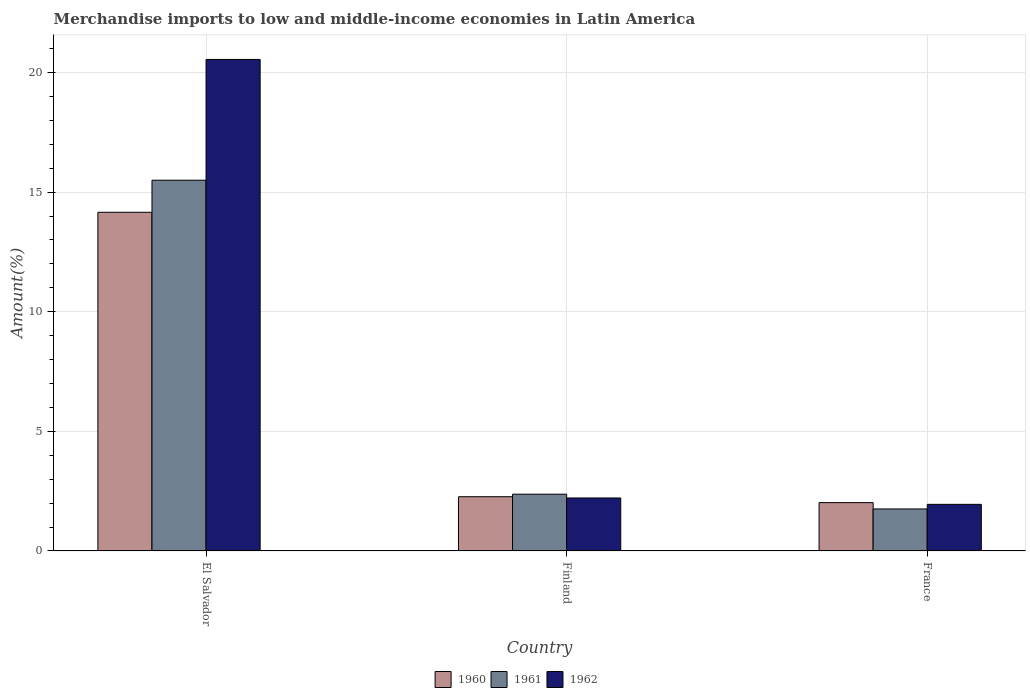How many different coloured bars are there?
Provide a succinct answer. 3. How many groups of bars are there?
Offer a very short reply. 3. Are the number of bars per tick equal to the number of legend labels?
Offer a terse response. Yes. Are the number of bars on each tick of the X-axis equal?
Your answer should be compact. Yes. What is the label of the 1st group of bars from the left?
Offer a terse response. El Salvador. What is the percentage of amount earned from merchandise imports in 1960 in France?
Ensure brevity in your answer.  2.02. Across all countries, what is the maximum percentage of amount earned from merchandise imports in 1961?
Ensure brevity in your answer.  15.5. Across all countries, what is the minimum percentage of amount earned from merchandise imports in 1960?
Ensure brevity in your answer.  2.02. In which country was the percentage of amount earned from merchandise imports in 1961 maximum?
Keep it short and to the point. El Salvador. In which country was the percentage of amount earned from merchandise imports in 1961 minimum?
Ensure brevity in your answer.  France. What is the total percentage of amount earned from merchandise imports in 1960 in the graph?
Your response must be concise. 18.45. What is the difference between the percentage of amount earned from merchandise imports in 1961 in El Salvador and that in France?
Your answer should be very brief. 13.74. What is the difference between the percentage of amount earned from merchandise imports in 1962 in El Salvador and the percentage of amount earned from merchandise imports in 1960 in Finland?
Give a very brief answer. 18.28. What is the average percentage of amount earned from merchandise imports in 1960 per country?
Your answer should be compact. 6.15. What is the difference between the percentage of amount earned from merchandise imports of/in 1962 and percentage of amount earned from merchandise imports of/in 1960 in France?
Your answer should be very brief. -0.07. In how many countries, is the percentage of amount earned from merchandise imports in 1962 greater than 1 %?
Offer a very short reply. 3. What is the ratio of the percentage of amount earned from merchandise imports in 1960 in El Salvador to that in France?
Your answer should be compact. 7. Is the percentage of amount earned from merchandise imports in 1961 in El Salvador less than that in France?
Your answer should be compact. No. What is the difference between the highest and the second highest percentage of amount earned from merchandise imports in 1960?
Your answer should be compact. 0.25. What is the difference between the highest and the lowest percentage of amount earned from merchandise imports in 1962?
Make the answer very short. 18.6. Is the sum of the percentage of amount earned from merchandise imports in 1961 in El Salvador and Finland greater than the maximum percentage of amount earned from merchandise imports in 1960 across all countries?
Ensure brevity in your answer.  Yes. What does the 1st bar from the right in El Salvador represents?
Your answer should be very brief. 1962. Is it the case that in every country, the sum of the percentage of amount earned from merchandise imports in 1960 and percentage of amount earned from merchandise imports in 1962 is greater than the percentage of amount earned from merchandise imports in 1961?
Offer a terse response. Yes. How many bars are there?
Ensure brevity in your answer.  9. How many countries are there in the graph?
Offer a very short reply. 3. Where does the legend appear in the graph?
Offer a very short reply. Bottom center. How many legend labels are there?
Offer a terse response. 3. What is the title of the graph?
Ensure brevity in your answer.  Merchandise imports to low and middle-income economies in Latin America. What is the label or title of the X-axis?
Your answer should be compact. Country. What is the label or title of the Y-axis?
Your answer should be very brief. Amount(%). What is the Amount(%) of 1960 in El Salvador?
Provide a short and direct response. 14.16. What is the Amount(%) of 1961 in El Salvador?
Your response must be concise. 15.5. What is the Amount(%) of 1962 in El Salvador?
Ensure brevity in your answer.  20.55. What is the Amount(%) of 1960 in Finland?
Your response must be concise. 2.27. What is the Amount(%) in 1961 in Finland?
Ensure brevity in your answer.  2.37. What is the Amount(%) in 1962 in Finland?
Your answer should be compact. 2.22. What is the Amount(%) of 1960 in France?
Make the answer very short. 2.02. What is the Amount(%) in 1961 in France?
Ensure brevity in your answer.  1.76. What is the Amount(%) in 1962 in France?
Ensure brevity in your answer.  1.95. Across all countries, what is the maximum Amount(%) of 1960?
Give a very brief answer. 14.16. Across all countries, what is the maximum Amount(%) of 1961?
Provide a short and direct response. 15.5. Across all countries, what is the maximum Amount(%) in 1962?
Keep it short and to the point. 20.55. Across all countries, what is the minimum Amount(%) of 1960?
Your response must be concise. 2.02. Across all countries, what is the minimum Amount(%) of 1961?
Make the answer very short. 1.76. Across all countries, what is the minimum Amount(%) in 1962?
Offer a terse response. 1.95. What is the total Amount(%) of 1960 in the graph?
Offer a terse response. 18.45. What is the total Amount(%) of 1961 in the graph?
Your answer should be very brief. 19.63. What is the total Amount(%) of 1962 in the graph?
Your response must be concise. 24.71. What is the difference between the Amount(%) in 1960 in El Salvador and that in Finland?
Ensure brevity in your answer.  11.89. What is the difference between the Amount(%) of 1961 in El Salvador and that in Finland?
Provide a short and direct response. 13.12. What is the difference between the Amount(%) in 1962 in El Salvador and that in Finland?
Provide a short and direct response. 18.33. What is the difference between the Amount(%) in 1960 in El Salvador and that in France?
Provide a short and direct response. 12.14. What is the difference between the Amount(%) in 1961 in El Salvador and that in France?
Offer a very short reply. 13.74. What is the difference between the Amount(%) of 1962 in El Salvador and that in France?
Keep it short and to the point. 18.6. What is the difference between the Amount(%) in 1960 in Finland and that in France?
Your answer should be very brief. 0.25. What is the difference between the Amount(%) of 1961 in Finland and that in France?
Your answer should be very brief. 0.62. What is the difference between the Amount(%) in 1962 in Finland and that in France?
Give a very brief answer. 0.27. What is the difference between the Amount(%) of 1960 in El Salvador and the Amount(%) of 1961 in Finland?
Give a very brief answer. 11.78. What is the difference between the Amount(%) in 1960 in El Salvador and the Amount(%) in 1962 in Finland?
Your response must be concise. 11.94. What is the difference between the Amount(%) of 1961 in El Salvador and the Amount(%) of 1962 in Finland?
Offer a terse response. 13.28. What is the difference between the Amount(%) of 1960 in El Salvador and the Amount(%) of 1961 in France?
Offer a terse response. 12.4. What is the difference between the Amount(%) of 1960 in El Salvador and the Amount(%) of 1962 in France?
Give a very brief answer. 12.21. What is the difference between the Amount(%) of 1961 in El Salvador and the Amount(%) of 1962 in France?
Your response must be concise. 13.55. What is the difference between the Amount(%) in 1960 in Finland and the Amount(%) in 1961 in France?
Make the answer very short. 0.51. What is the difference between the Amount(%) in 1960 in Finland and the Amount(%) in 1962 in France?
Provide a succinct answer. 0.32. What is the difference between the Amount(%) of 1961 in Finland and the Amount(%) of 1962 in France?
Ensure brevity in your answer.  0.42. What is the average Amount(%) of 1960 per country?
Give a very brief answer. 6.15. What is the average Amount(%) of 1961 per country?
Provide a succinct answer. 6.54. What is the average Amount(%) of 1962 per country?
Provide a short and direct response. 8.24. What is the difference between the Amount(%) in 1960 and Amount(%) in 1961 in El Salvador?
Your answer should be compact. -1.34. What is the difference between the Amount(%) in 1960 and Amount(%) in 1962 in El Salvador?
Your answer should be very brief. -6.39. What is the difference between the Amount(%) in 1961 and Amount(%) in 1962 in El Salvador?
Provide a short and direct response. -5.05. What is the difference between the Amount(%) in 1960 and Amount(%) in 1961 in Finland?
Your response must be concise. -0.11. What is the difference between the Amount(%) of 1960 and Amount(%) of 1962 in Finland?
Ensure brevity in your answer.  0.05. What is the difference between the Amount(%) of 1961 and Amount(%) of 1962 in Finland?
Offer a terse response. 0.16. What is the difference between the Amount(%) in 1960 and Amount(%) in 1961 in France?
Provide a short and direct response. 0.26. What is the difference between the Amount(%) of 1960 and Amount(%) of 1962 in France?
Provide a short and direct response. 0.07. What is the difference between the Amount(%) in 1961 and Amount(%) in 1962 in France?
Your answer should be very brief. -0.19. What is the ratio of the Amount(%) in 1960 in El Salvador to that in Finland?
Provide a short and direct response. 6.24. What is the ratio of the Amount(%) in 1961 in El Salvador to that in Finland?
Ensure brevity in your answer.  6.53. What is the ratio of the Amount(%) in 1962 in El Salvador to that in Finland?
Provide a short and direct response. 9.27. What is the ratio of the Amount(%) in 1960 in El Salvador to that in France?
Your answer should be compact. 7. What is the ratio of the Amount(%) of 1961 in El Salvador to that in France?
Make the answer very short. 8.82. What is the ratio of the Amount(%) of 1962 in El Salvador to that in France?
Offer a very short reply. 10.54. What is the ratio of the Amount(%) of 1960 in Finland to that in France?
Provide a succinct answer. 1.12. What is the ratio of the Amount(%) of 1961 in Finland to that in France?
Your answer should be compact. 1.35. What is the ratio of the Amount(%) in 1962 in Finland to that in France?
Provide a short and direct response. 1.14. What is the difference between the highest and the second highest Amount(%) in 1960?
Keep it short and to the point. 11.89. What is the difference between the highest and the second highest Amount(%) in 1961?
Ensure brevity in your answer.  13.12. What is the difference between the highest and the second highest Amount(%) of 1962?
Provide a short and direct response. 18.33. What is the difference between the highest and the lowest Amount(%) in 1960?
Ensure brevity in your answer.  12.14. What is the difference between the highest and the lowest Amount(%) in 1961?
Ensure brevity in your answer.  13.74. What is the difference between the highest and the lowest Amount(%) of 1962?
Your response must be concise. 18.6. 